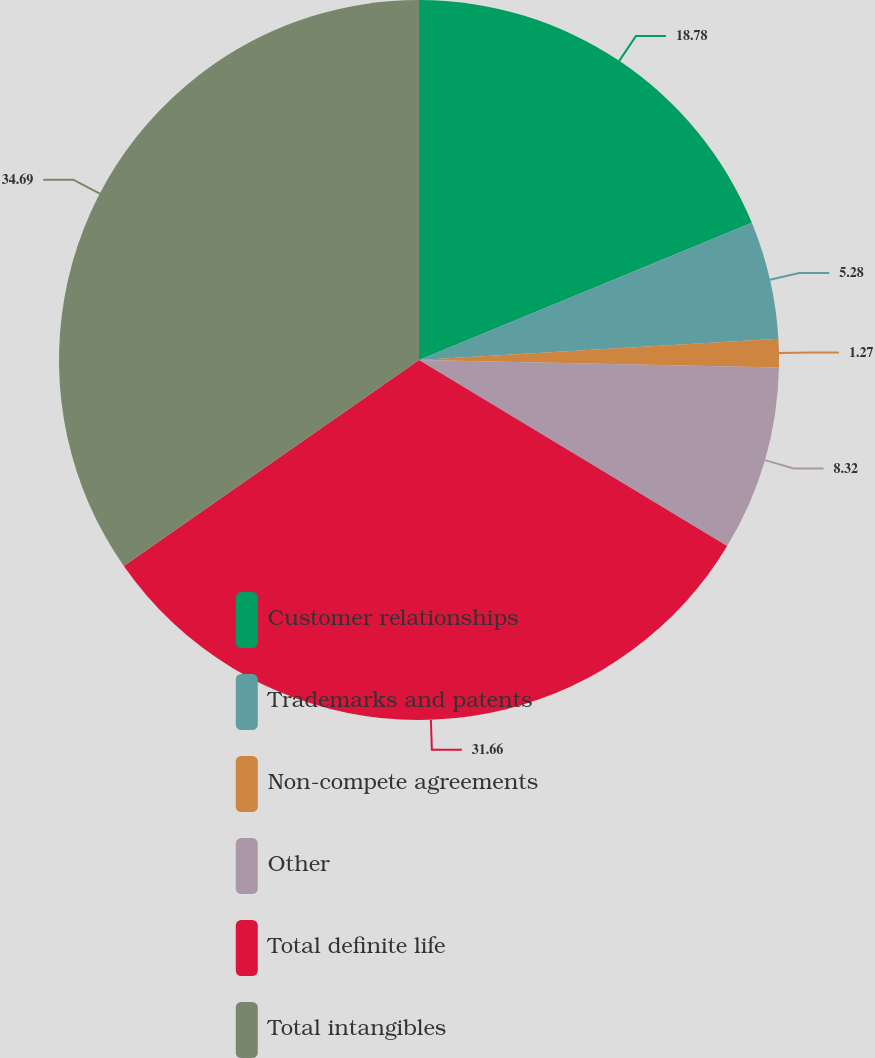<chart> <loc_0><loc_0><loc_500><loc_500><pie_chart><fcel>Customer relationships<fcel>Trademarks and patents<fcel>Non-compete agreements<fcel>Other<fcel>Total definite life<fcel>Total intangibles<nl><fcel>18.78%<fcel>5.28%<fcel>1.27%<fcel>8.32%<fcel>31.66%<fcel>34.7%<nl></chart> 